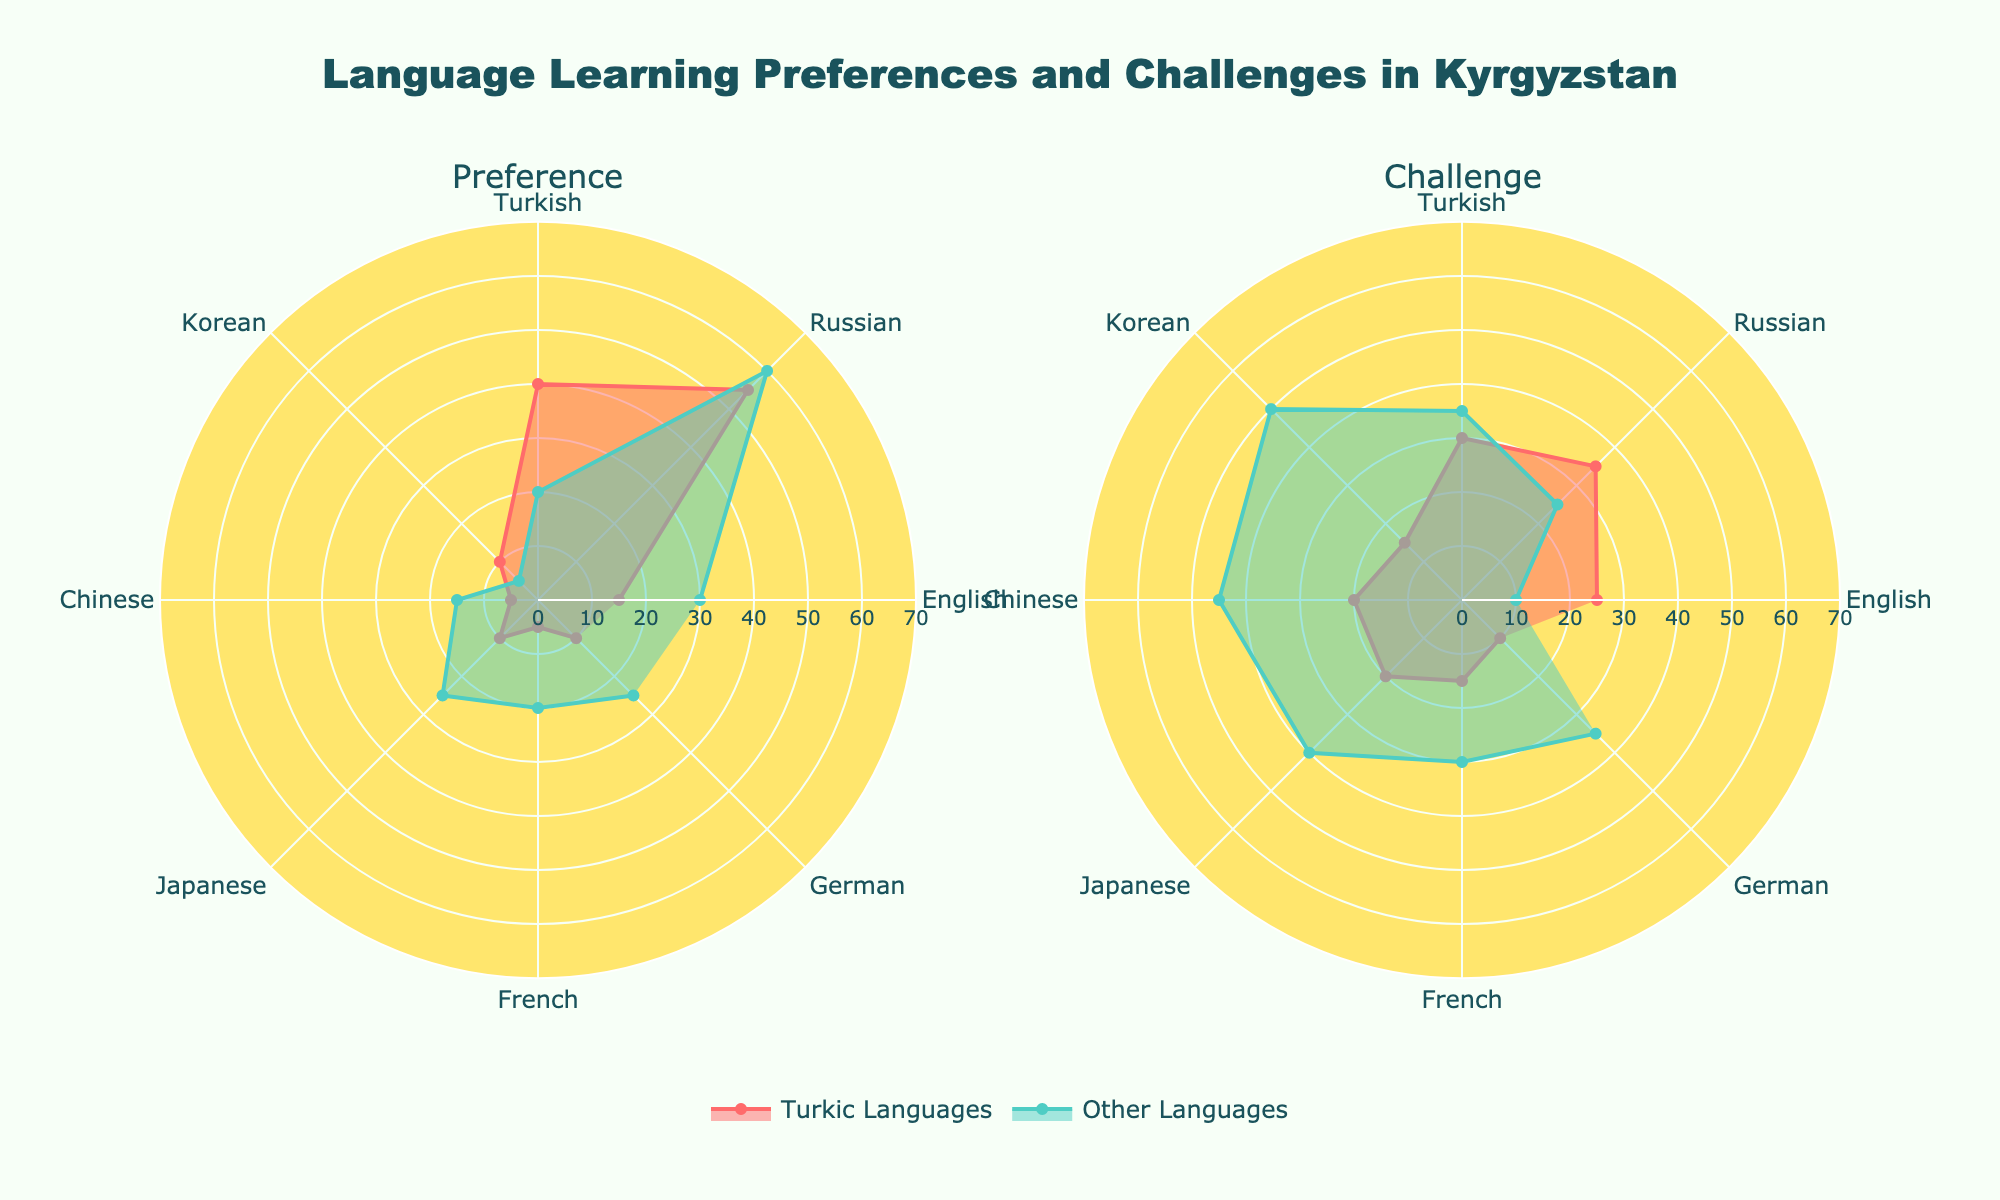Which language has the highest preference for learning Turkic languages? Looking at the "Preference" subplot, the highest value for Turkic languages is 55 for Russian.
Answer: Russian Which language shows the biggest difference between preferences for Turkic and other foreign languages? For each language, subtract the preference for other languages from the preference for Turkic languages and compare the differences: Russian (55-60=-5), Turkish (40-20=20), English (15-30=-15), Korean (10-5=5), Chinese (5-15=-10), Japanese (10-25=-15), French (5-20=-15), German (10-25=-15). The biggest difference is for Turkish (20).
Answer: Turkish How do the challenges in learning Korean compare between Turkic and other languages? In the "Challenge" subplot, the values for Korean are 15 for Turkic languages and 50 for other foreign languages. 50 is greater than 15.
Answer: Challenges are higher for other languages What are the total preferences for Turkic languages across all languages? Summing up the preference values for Turkic languages: 15 (English) + 55 (Russian) + 40 (Turkish) + 10 (Korean) + 5 (Chinese) + 10 (Japanese) + 5 (French) + 10 (German) = 150.
Answer: 150 Which language has the least challenge in learning Turkic languages? Refer to the "Challenge" subplot; the lowest value for Turkic languages is 10 for English and German.
Answer: English and German What is the difference in challenges between learning Japanese in Turkic and other languages? In the "Challenge" subplot, the values for Japanese are 20 for Turkic languages and 40 for other languages. The difference is 40 - 20 = 20.
Answer: 20 For which languages is the preference for other languages higher than 20? Checking the "Preference" subplot, the languages with other preferences higher than 20 are English (30), Russian (60), Japanese (25), French (20), and German (25).
Answer: English, Russian, Japanese, German What is the average challenge for learning other languages across all categories? The challenge values for other languages are: 10 (English) + 25 (Russian) + 35 (Turkish) + 50 (Korean) + 45 (Chinese) + 40 (Japanese) + 30 (French) + 35 (German) = 270. There are 8 languages, so the average is 270 / 8 = 33.75.
Answer: 33.75 Which language shows the nearest challenge levels between Turkic and other foreign languages? Compare the challenge values: English (15), Russian (10), Turkish (5), Korean (35), Chinese (25), Japanese (20), French (15), German (25). The smallest difference is 5 (Turkish, 30 vs. 35).
Answer: Turkish What is the combined preference for English, Russian, and Turkish for Turkic languages? Summing up their values for Turkic languages: 15 (English) + 55 (Russian) + 40 (Turkish) = 110.
Answer: 110 